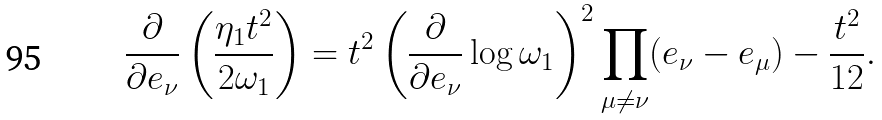Convert formula to latex. <formula><loc_0><loc_0><loc_500><loc_500>\frac { \partial } { \partial e _ { \nu } } \left ( \frac { \eta _ { 1 } t ^ { 2 } } { 2 \omega _ { 1 } } \right ) = t ^ { 2 } \left ( \frac { \partial } { \partial e _ { \nu } } \log \omega _ { 1 } \right ) ^ { 2 } \prod _ { \mu \neq \nu } ( e _ { \nu } - e _ { \mu } ) - \frac { t ^ { 2 } } { 1 2 } .</formula> 